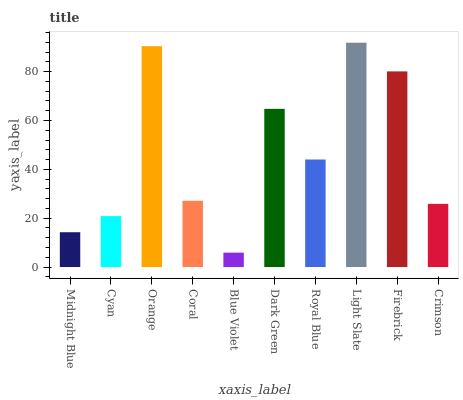Is Cyan the minimum?
Answer yes or no. No. Is Cyan the maximum?
Answer yes or no. No. Is Cyan greater than Midnight Blue?
Answer yes or no. Yes. Is Midnight Blue less than Cyan?
Answer yes or no. Yes. Is Midnight Blue greater than Cyan?
Answer yes or no. No. Is Cyan less than Midnight Blue?
Answer yes or no. No. Is Royal Blue the high median?
Answer yes or no. Yes. Is Coral the low median?
Answer yes or no. Yes. Is Coral the high median?
Answer yes or no. No. Is Dark Green the low median?
Answer yes or no. No. 